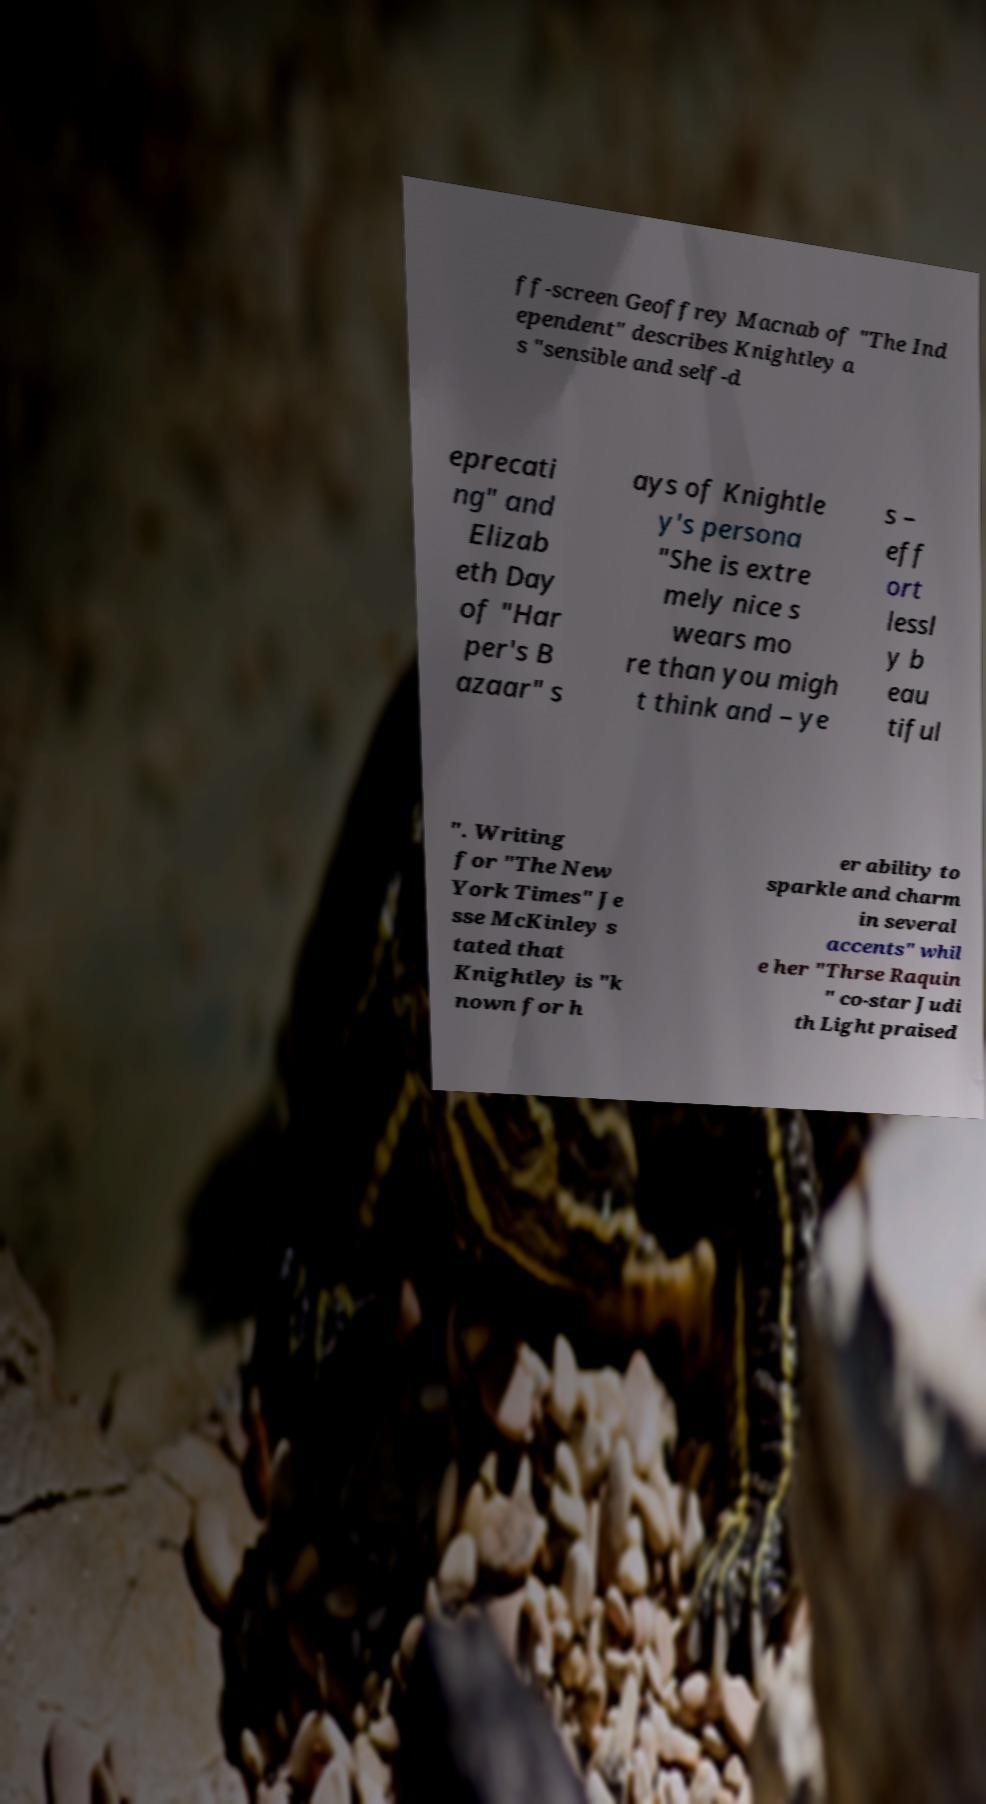What messages or text are displayed in this image? I need them in a readable, typed format. ff-screen Geoffrey Macnab of "The Ind ependent" describes Knightley a s "sensible and self-d eprecati ng" and Elizab eth Day of "Har per's B azaar" s ays of Knightle y's persona "She is extre mely nice s wears mo re than you migh t think and – ye s – eff ort lessl y b eau tiful ". Writing for "The New York Times" Je sse McKinley s tated that Knightley is "k nown for h er ability to sparkle and charm in several accents" whil e her "Thrse Raquin " co-star Judi th Light praised 